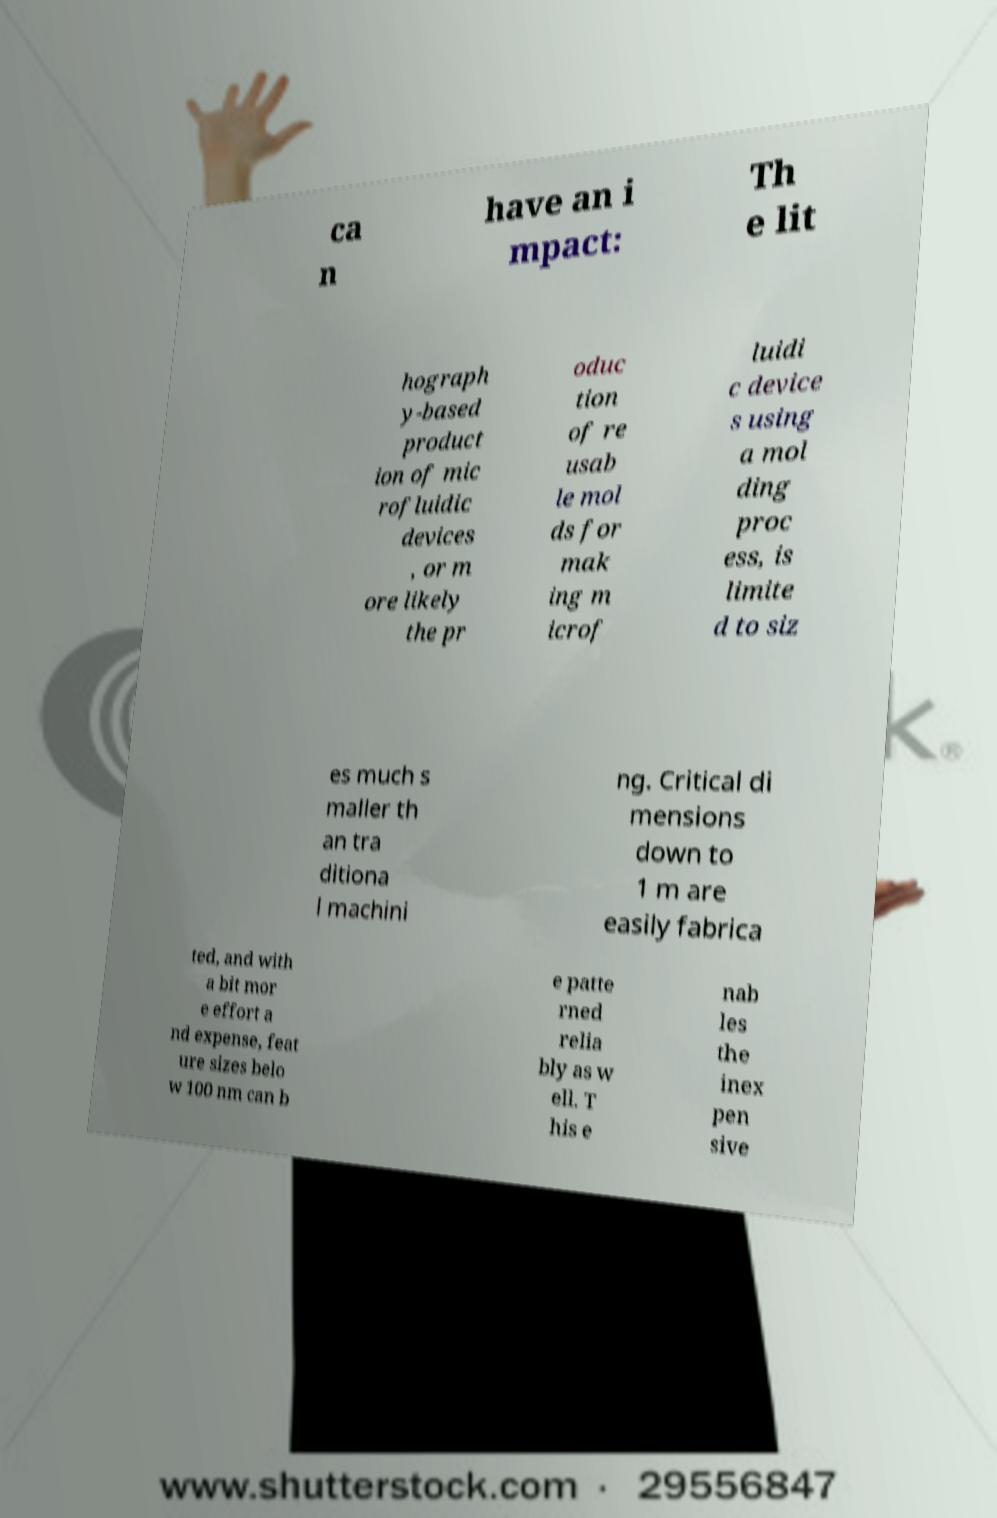Could you assist in decoding the text presented in this image and type it out clearly? ca n have an i mpact: Th e lit hograph y-based product ion of mic rofluidic devices , or m ore likely the pr oduc tion of re usab le mol ds for mak ing m icrof luidi c device s using a mol ding proc ess, is limite d to siz es much s maller th an tra ditiona l machini ng. Critical di mensions down to 1 m are easily fabrica ted, and with a bit mor e effort a nd expense, feat ure sizes belo w 100 nm can b e patte rned relia bly as w ell. T his e nab les the inex pen sive 